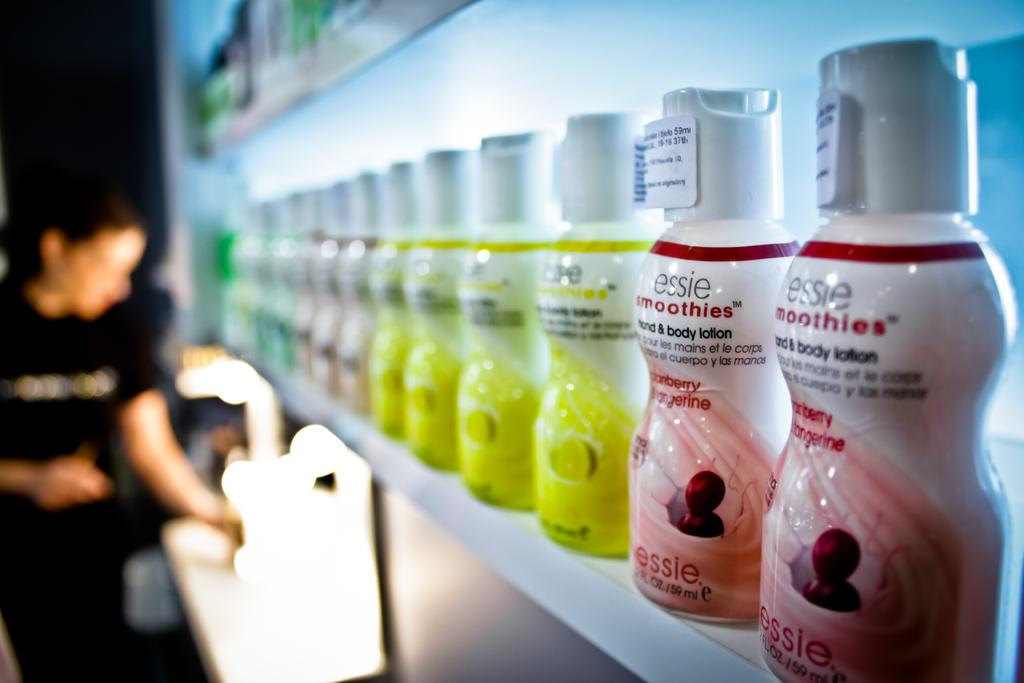What is the color of the rack in the image? The rack in the image is white. What is being stored in the rack? There are bottles arranged in the white color rack. Where is the person located in the image? The person is standing on the left side of the image. What color is the dress the person is wearing? The person is wearing a black color dress. Can you tell me how many snails are crawling on the person's dress in the image? There are no snails present in the image; the person is wearing a black color dress. What type of soap is being used to clean the bottles in the image? There is no soap or cleaning activity depicted in the image; it only shows bottles arranged in a white color rack and a person standing on the left side. 